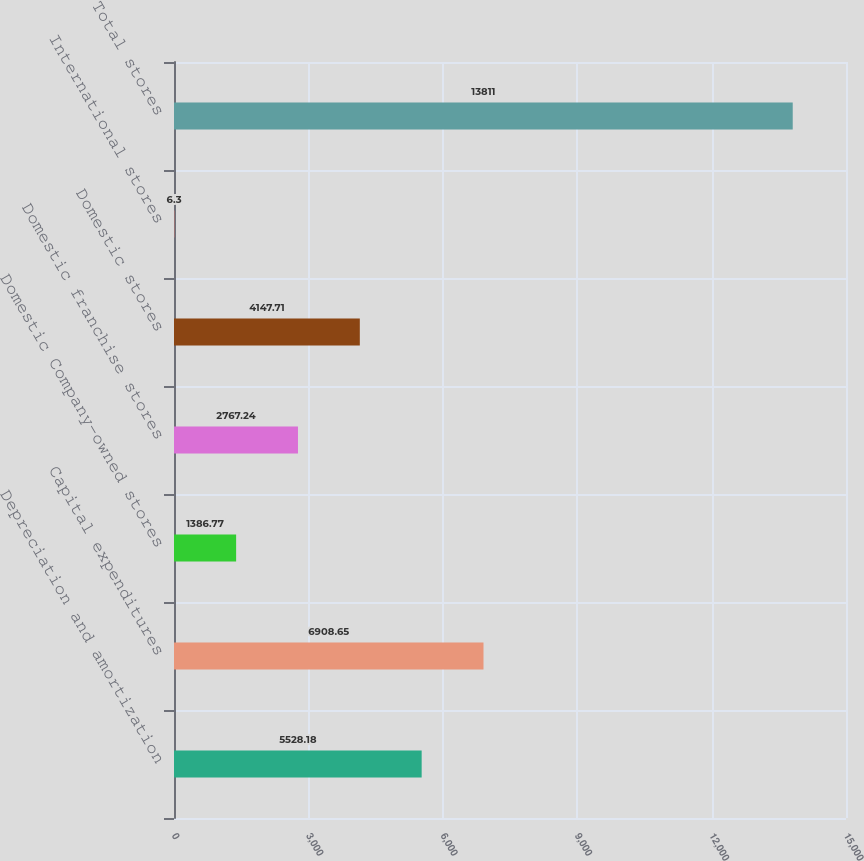<chart> <loc_0><loc_0><loc_500><loc_500><bar_chart><fcel>Depreciation and amortization<fcel>Capital expenditures<fcel>Domestic Company-owned stores<fcel>Domestic franchise stores<fcel>Domestic stores<fcel>International stores<fcel>Total stores<nl><fcel>5528.18<fcel>6908.65<fcel>1386.77<fcel>2767.24<fcel>4147.71<fcel>6.3<fcel>13811<nl></chart> 